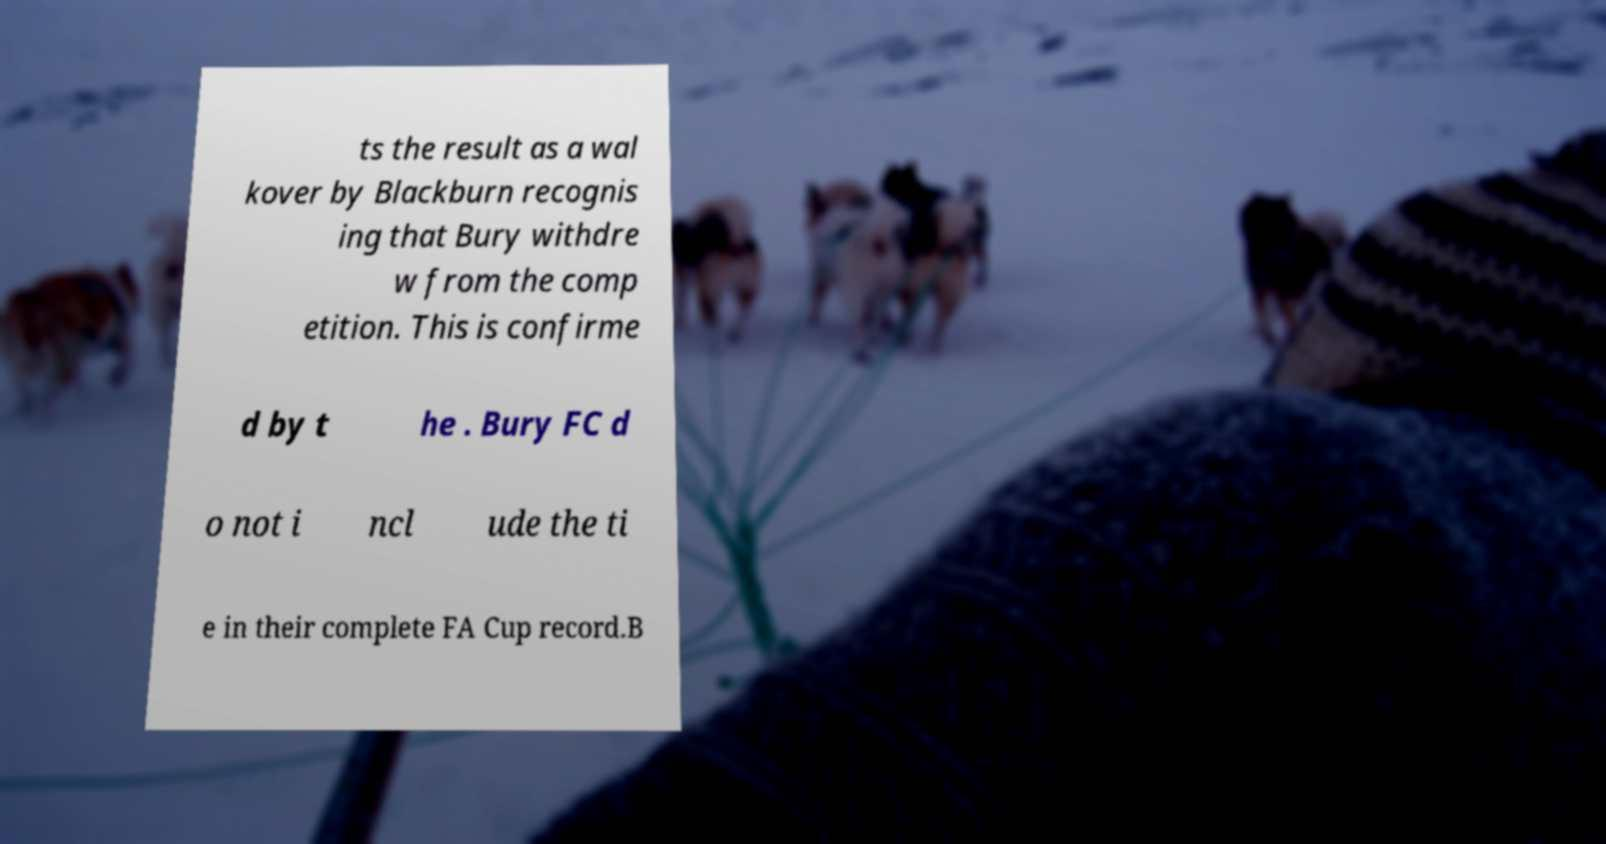There's text embedded in this image that I need extracted. Can you transcribe it verbatim? ts the result as a wal kover by Blackburn recognis ing that Bury withdre w from the comp etition. This is confirme d by t he . Bury FC d o not i ncl ude the ti e in their complete FA Cup record.B 